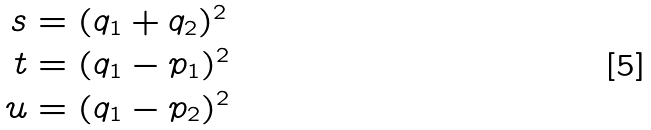<formula> <loc_0><loc_0><loc_500><loc_500>s & = ( q _ { 1 } + q _ { 2 } ) ^ { 2 } \\ t & = ( q _ { 1 } - p _ { 1 } ) ^ { 2 } \\ u & = ( q _ { 1 } - p _ { 2 } ) ^ { 2 }</formula> 